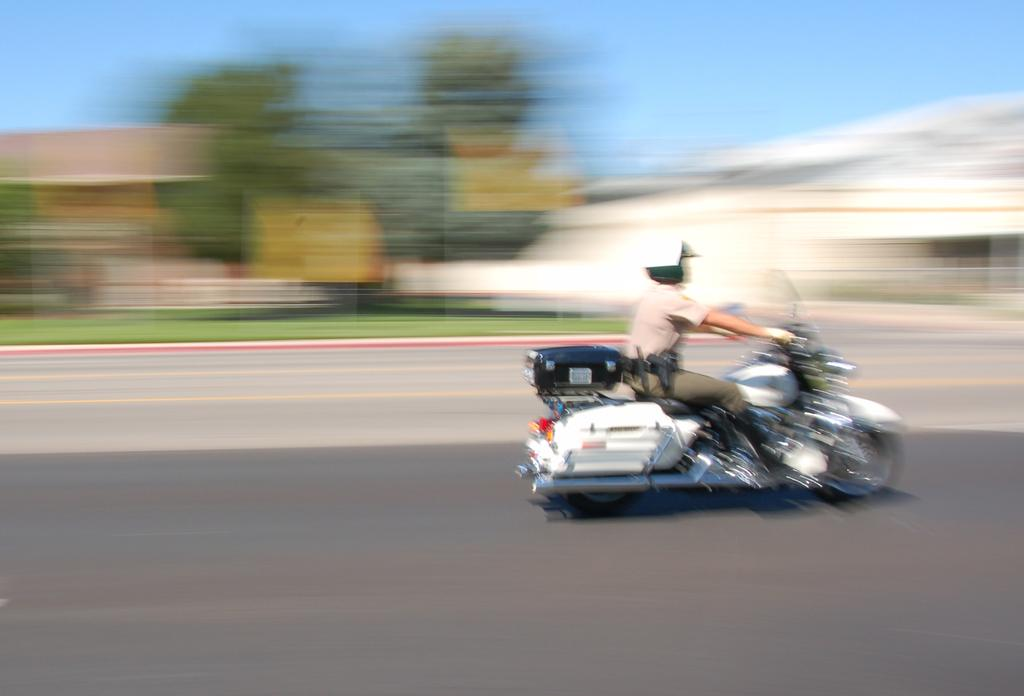What is the main subject of the image? The main subject of the image is a motorbike. How is the motorbike depicted in the image? The motorbike is moving fast in the image. Where is the motorbike located? The motorbike is on the road in the image. What can be seen in the background of the image? There are buildings and trees in the background of the image. How many babies are being helped by the chickens in the image? There are no babies or chickens present in the image; it features a motorbike on the road. 